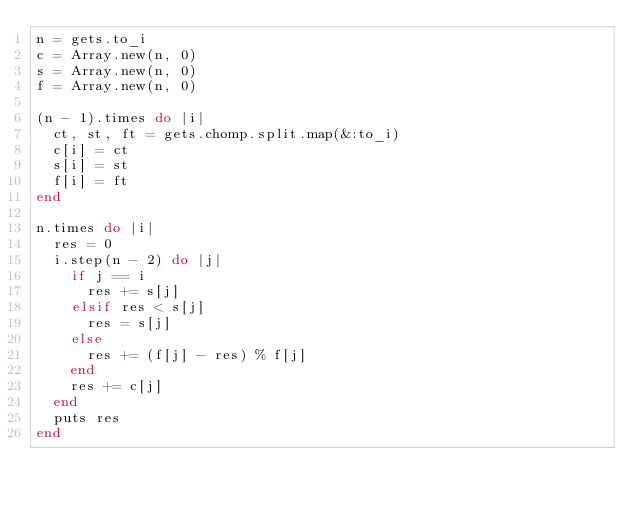<code> <loc_0><loc_0><loc_500><loc_500><_Ruby_>n = gets.to_i
c = Array.new(n, 0)
s = Array.new(n, 0)
f = Array.new(n, 0)

(n - 1).times do |i|
  ct, st, ft = gets.chomp.split.map(&:to_i)
  c[i] = ct
  s[i] = st
  f[i] = ft
end

n.times do |i|
  res = 0
  i.step(n - 2) do |j|
    if j == i
      res += s[j]
    elsif res < s[j]
      res = s[j]
    else
      res += (f[j] - res) % f[j]
    end
    res += c[j]
  end
  puts res
end</code> 